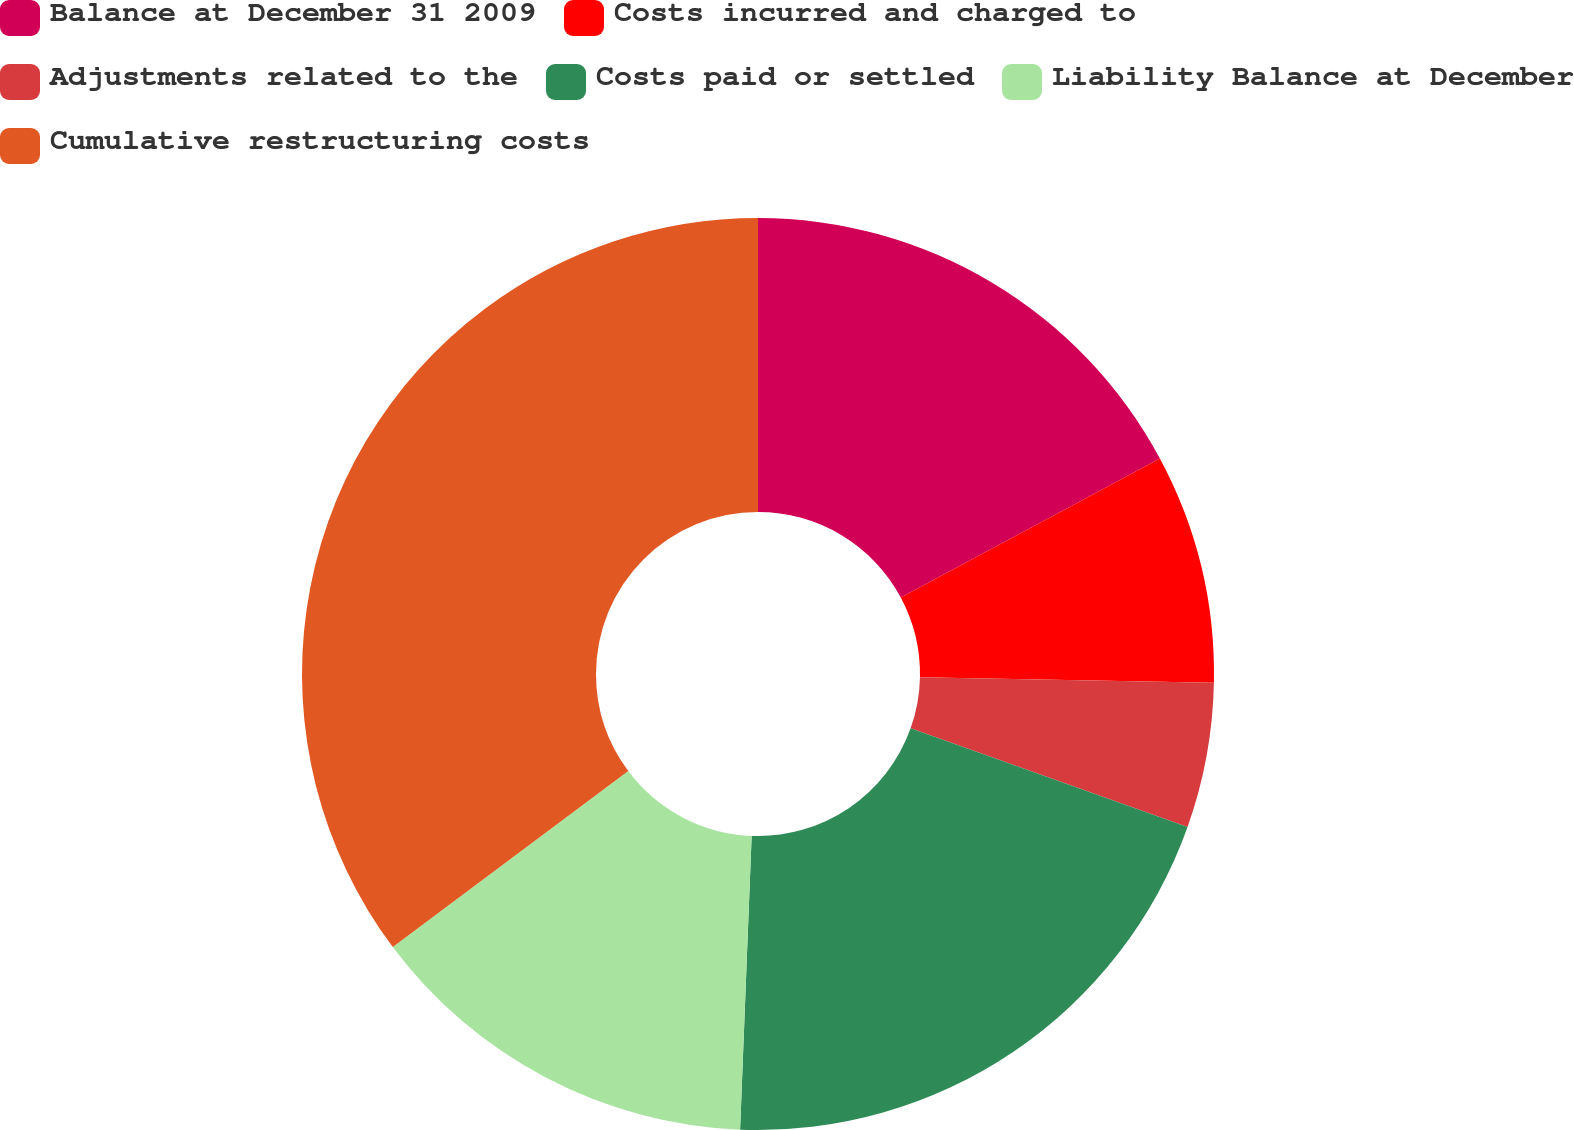<chart> <loc_0><loc_0><loc_500><loc_500><pie_chart><fcel>Balance at December 31 2009<fcel>Costs incurred and charged to<fcel>Adjustments related to the<fcel>Costs paid or settled<fcel>Liability Balance at December<fcel>Cumulative restructuring costs<nl><fcel>17.17%<fcel>8.14%<fcel>5.14%<fcel>20.18%<fcel>14.16%<fcel>35.22%<nl></chart> 